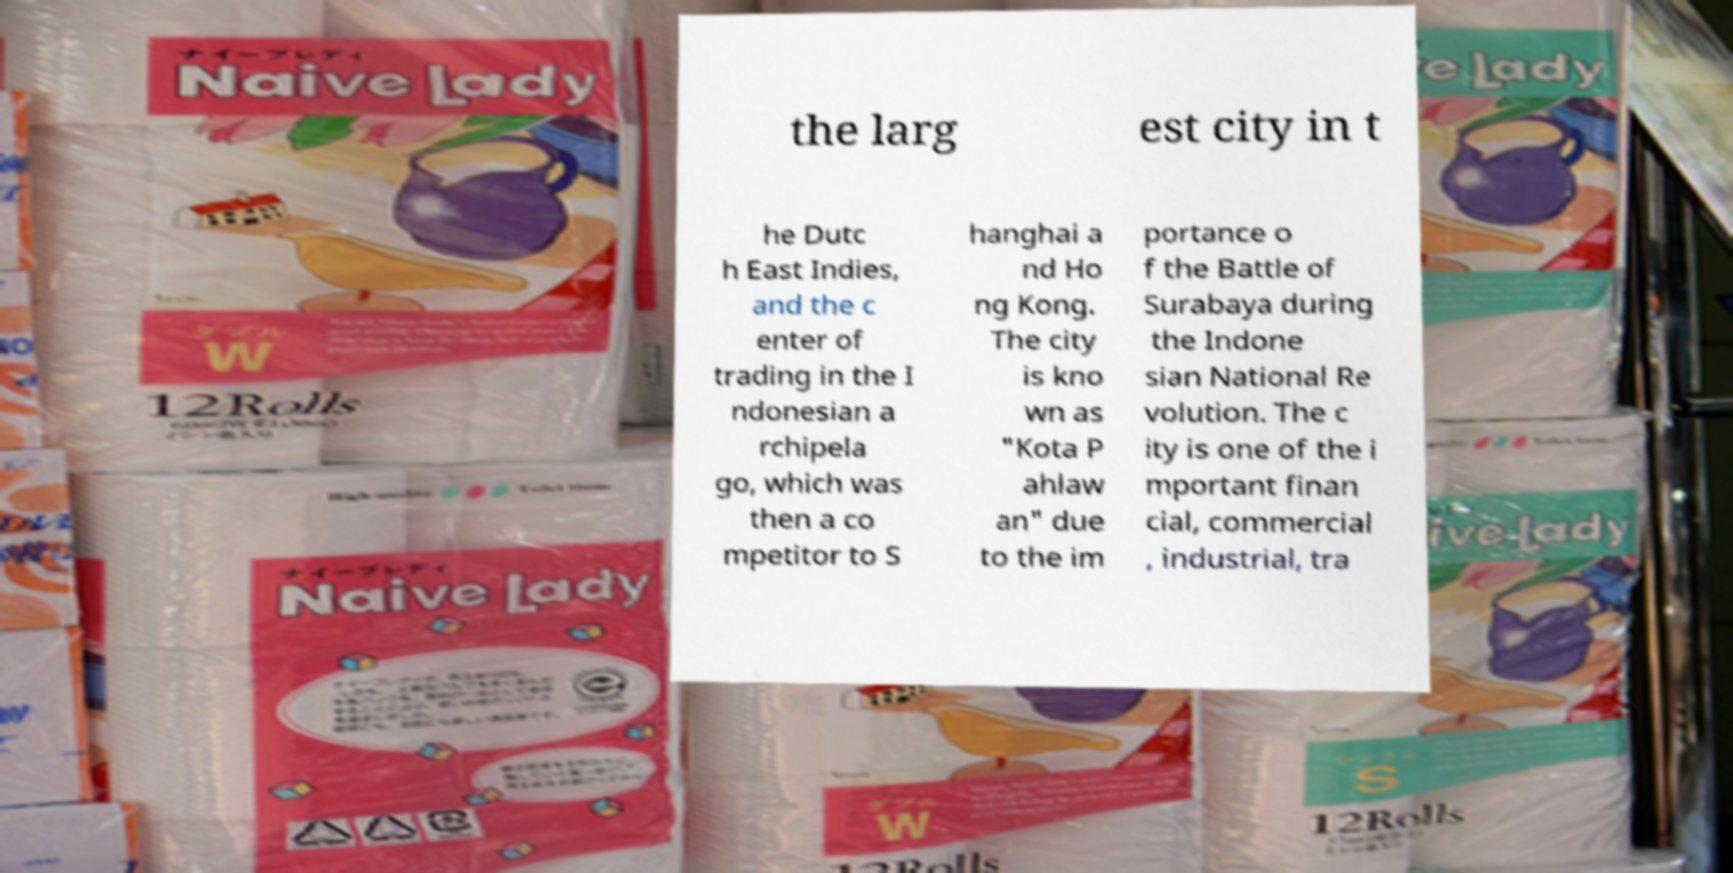Can you accurately transcribe the text from the provided image for me? the larg est city in t he Dutc h East Indies, and the c enter of trading in the I ndonesian a rchipela go, which was then a co mpetitor to S hanghai a nd Ho ng Kong. The city is kno wn as "Kota P ahlaw an" due to the im portance o f the Battle of Surabaya during the Indone sian National Re volution. The c ity is one of the i mportant finan cial, commercial , industrial, tra 